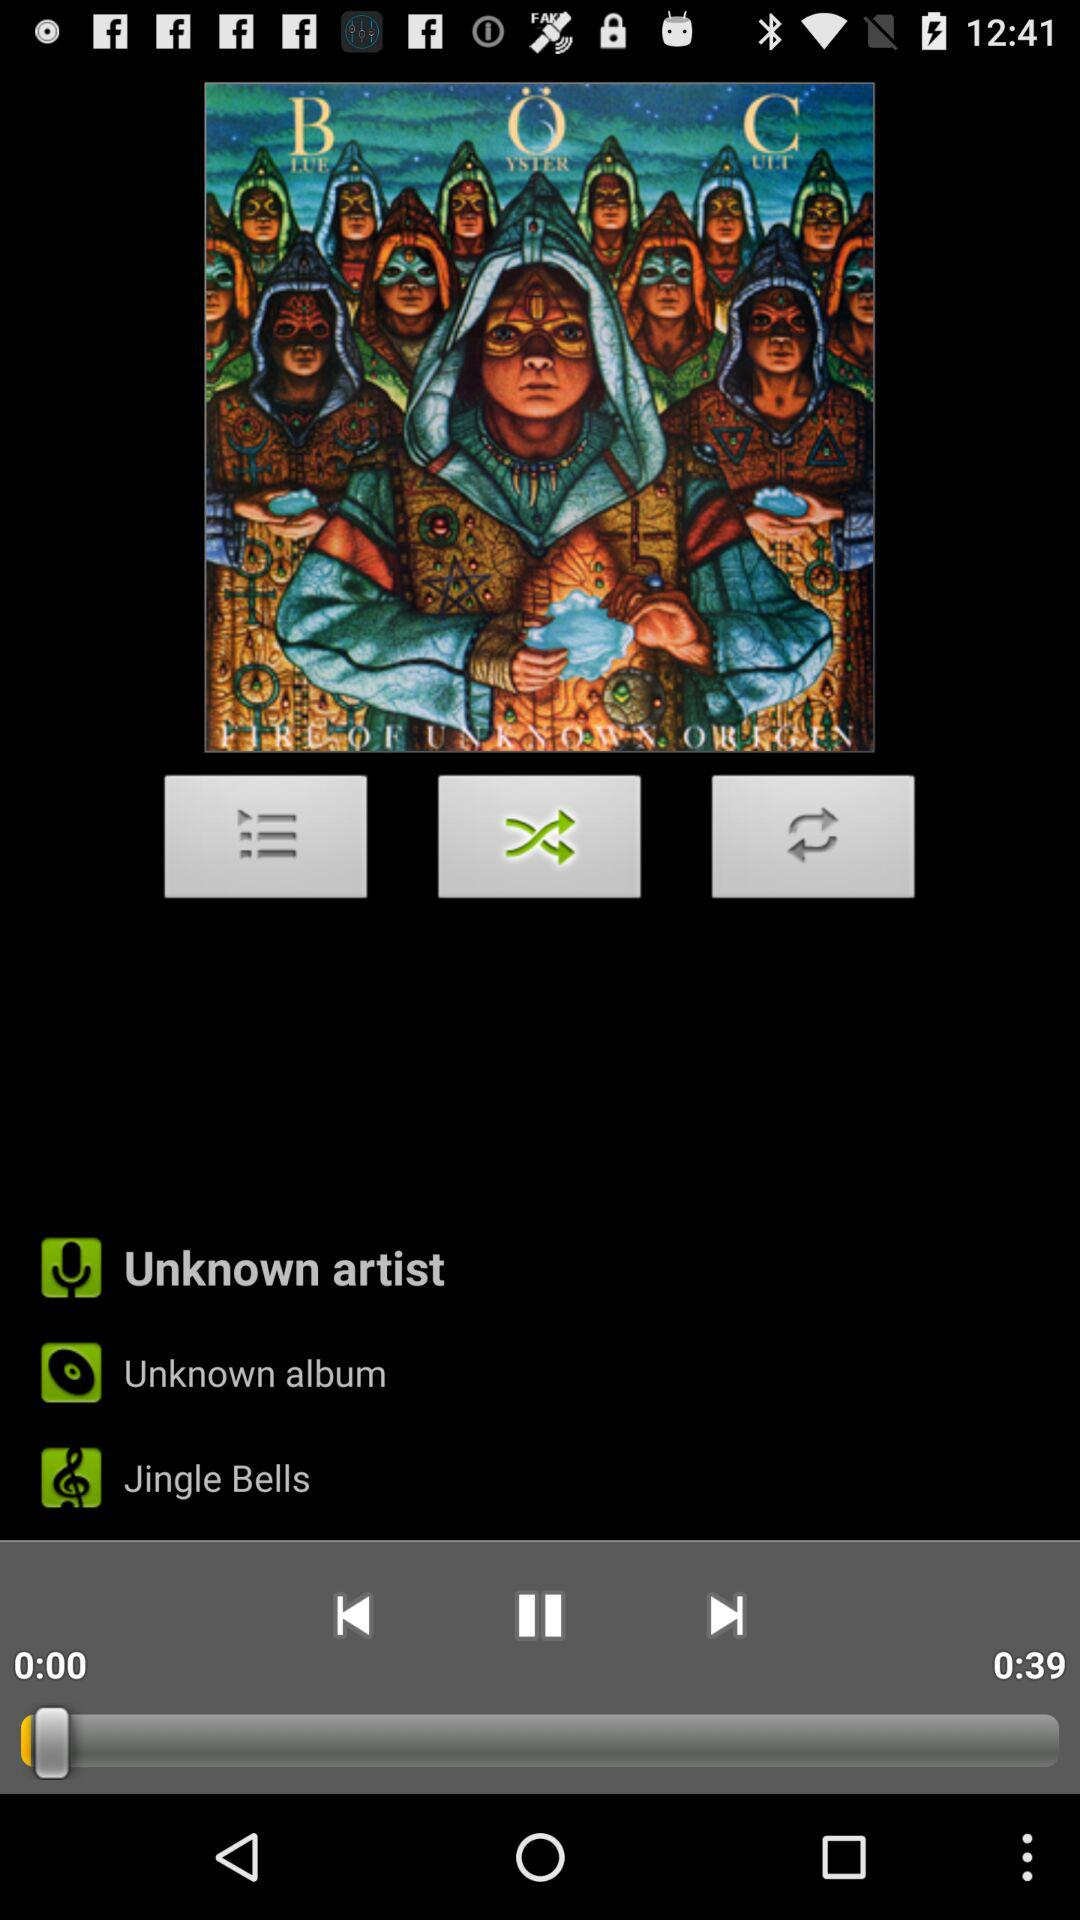What is the total duration of the video? The total duration of the video is 39 seconds. 